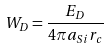Convert formula to latex. <formula><loc_0><loc_0><loc_500><loc_500>W _ { D } = \frac { E _ { D } } { 4 \pi a _ { S i } r _ { c } }</formula> 